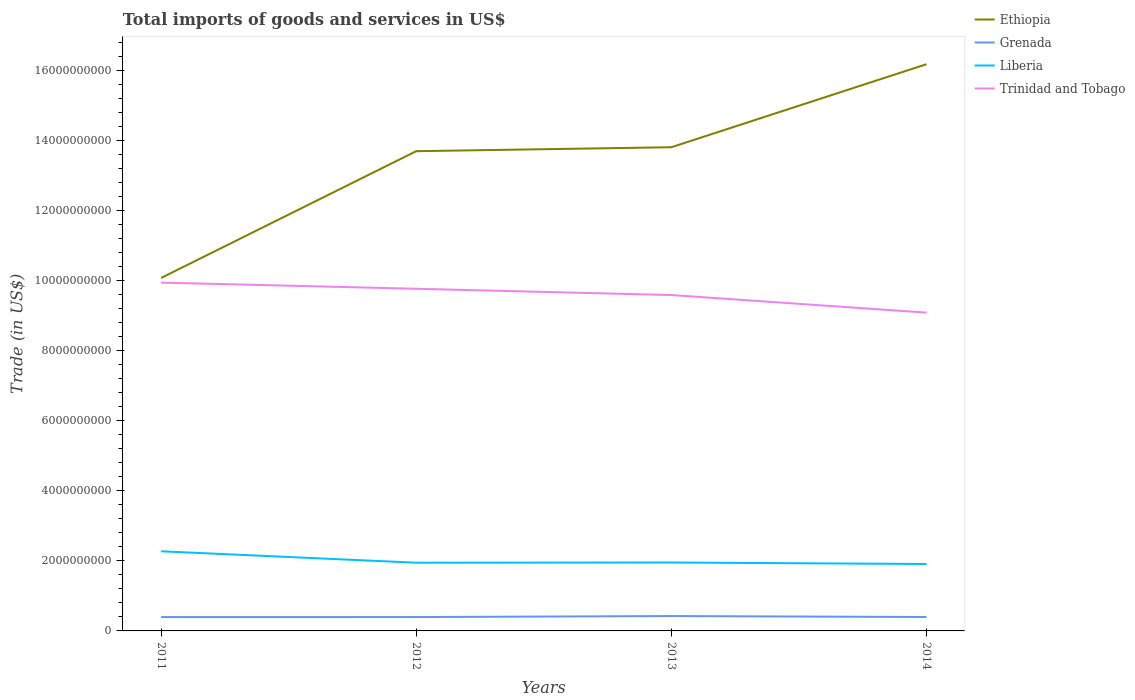Is the number of lines equal to the number of legend labels?
Offer a very short reply. Yes. Across all years, what is the maximum total imports of goods and services in Grenada?
Your answer should be compact. 3.95e+08. What is the total total imports of goods and services in Grenada in the graph?
Make the answer very short. -1.56e+06. What is the difference between the highest and the second highest total imports of goods and services in Trinidad and Tobago?
Offer a terse response. 8.57e+08. How many lines are there?
Keep it short and to the point. 4. How many years are there in the graph?
Offer a very short reply. 4. What is the difference between two consecutive major ticks on the Y-axis?
Keep it short and to the point. 2.00e+09. Does the graph contain any zero values?
Provide a succinct answer. No. Does the graph contain grids?
Keep it short and to the point. No. How many legend labels are there?
Ensure brevity in your answer.  4. What is the title of the graph?
Make the answer very short. Total imports of goods and services in US$. Does "Azerbaijan" appear as one of the legend labels in the graph?
Your response must be concise. No. What is the label or title of the X-axis?
Provide a short and direct response. Years. What is the label or title of the Y-axis?
Provide a succinct answer. Trade (in US$). What is the Trade (in US$) of Ethiopia in 2011?
Keep it short and to the point. 1.01e+1. What is the Trade (in US$) of Grenada in 2011?
Keep it short and to the point. 3.95e+08. What is the Trade (in US$) in Liberia in 2011?
Provide a succinct answer. 2.27e+09. What is the Trade (in US$) in Trinidad and Tobago in 2011?
Provide a short and direct response. 9.95e+09. What is the Trade (in US$) in Ethiopia in 2012?
Your response must be concise. 1.37e+1. What is the Trade (in US$) in Grenada in 2012?
Your answer should be very brief. 3.96e+08. What is the Trade (in US$) in Liberia in 2012?
Provide a succinct answer. 1.95e+09. What is the Trade (in US$) of Trinidad and Tobago in 2012?
Your answer should be very brief. 9.77e+09. What is the Trade (in US$) in Ethiopia in 2013?
Give a very brief answer. 1.38e+1. What is the Trade (in US$) of Grenada in 2013?
Your response must be concise. 4.24e+08. What is the Trade (in US$) of Liberia in 2013?
Your answer should be compact. 1.95e+09. What is the Trade (in US$) in Trinidad and Tobago in 2013?
Make the answer very short. 9.59e+09. What is the Trade (in US$) of Ethiopia in 2014?
Make the answer very short. 1.62e+1. What is the Trade (in US$) of Grenada in 2014?
Offer a very short reply. 3.97e+08. What is the Trade (in US$) of Liberia in 2014?
Your answer should be compact. 1.91e+09. What is the Trade (in US$) in Trinidad and Tobago in 2014?
Give a very brief answer. 9.09e+09. Across all years, what is the maximum Trade (in US$) of Ethiopia?
Offer a very short reply. 1.62e+1. Across all years, what is the maximum Trade (in US$) in Grenada?
Make the answer very short. 4.24e+08. Across all years, what is the maximum Trade (in US$) of Liberia?
Ensure brevity in your answer.  2.27e+09. Across all years, what is the maximum Trade (in US$) in Trinidad and Tobago?
Your response must be concise. 9.95e+09. Across all years, what is the minimum Trade (in US$) in Ethiopia?
Offer a terse response. 1.01e+1. Across all years, what is the minimum Trade (in US$) of Grenada?
Offer a very short reply. 3.95e+08. Across all years, what is the minimum Trade (in US$) of Liberia?
Your answer should be compact. 1.91e+09. Across all years, what is the minimum Trade (in US$) in Trinidad and Tobago?
Ensure brevity in your answer.  9.09e+09. What is the total Trade (in US$) of Ethiopia in the graph?
Your answer should be compact. 5.38e+1. What is the total Trade (in US$) in Grenada in the graph?
Ensure brevity in your answer.  1.61e+09. What is the total Trade (in US$) in Liberia in the graph?
Provide a succinct answer. 8.09e+09. What is the total Trade (in US$) of Trinidad and Tobago in the graph?
Keep it short and to the point. 3.84e+1. What is the difference between the Trade (in US$) of Ethiopia in 2011 and that in 2012?
Your answer should be very brief. -3.62e+09. What is the difference between the Trade (in US$) of Grenada in 2011 and that in 2012?
Make the answer very short. -1.89e+05. What is the difference between the Trade (in US$) of Liberia in 2011 and that in 2012?
Keep it short and to the point. 3.26e+08. What is the difference between the Trade (in US$) of Trinidad and Tobago in 2011 and that in 2012?
Make the answer very short. 1.76e+08. What is the difference between the Trade (in US$) of Ethiopia in 2011 and that in 2013?
Keep it short and to the point. -3.73e+09. What is the difference between the Trade (in US$) in Grenada in 2011 and that in 2013?
Make the answer very short. -2.88e+07. What is the difference between the Trade (in US$) in Liberia in 2011 and that in 2013?
Offer a terse response. 3.20e+08. What is the difference between the Trade (in US$) in Trinidad and Tobago in 2011 and that in 2013?
Your response must be concise. 3.55e+08. What is the difference between the Trade (in US$) of Ethiopia in 2011 and that in 2014?
Your answer should be compact. -6.10e+09. What is the difference between the Trade (in US$) in Grenada in 2011 and that in 2014?
Keep it short and to the point. -1.56e+06. What is the difference between the Trade (in US$) of Liberia in 2011 and that in 2014?
Your answer should be compact. 3.63e+08. What is the difference between the Trade (in US$) in Trinidad and Tobago in 2011 and that in 2014?
Keep it short and to the point. 8.57e+08. What is the difference between the Trade (in US$) of Ethiopia in 2012 and that in 2013?
Provide a succinct answer. -1.13e+08. What is the difference between the Trade (in US$) in Grenada in 2012 and that in 2013?
Provide a succinct answer. -2.86e+07. What is the difference between the Trade (in US$) of Liberia in 2012 and that in 2013?
Provide a short and direct response. -6.00e+06. What is the difference between the Trade (in US$) of Trinidad and Tobago in 2012 and that in 2013?
Give a very brief answer. 1.79e+08. What is the difference between the Trade (in US$) in Ethiopia in 2012 and that in 2014?
Your answer should be compact. -2.48e+09. What is the difference between the Trade (in US$) in Grenada in 2012 and that in 2014?
Your answer should be very brief. -1.37e+06. What is the difference between the Trade (in US$) in Liberia in 2012 and that in 2014?
Your answer should be very brief. 3.70e+07. What is the difference between the Trade (in US$) in Trinidad and Tobago in 2012 and that in 2014?
Make the answer very short. 6.81e+08. What is the difference between the Trade (in US$) in Ethiopia in 2013 and that in 2014?
Your response must be concise. -2.37e+09. What is the difference between the Trade (in US$) of Grenada in 2013 and that in 2014?
Ensure brevity in your answer.  2.72e+07. What is the difference between the Trade (in US$) of Liberia in 2013 and that in 2014?
Keep it short and to the point. 4.30e+07. What is the difference between the Trade (in US$) in Trinidad and Tobago in 2013 and that in 2014?
Your answer should be compact. 5.02e+08. What is the difference between the Trade (in US$) of Ethiopia in 2011 and the Trade (in US$) of Grenada in 2012?
Ensure brevity in your answer.  9.68e+09. What is the difference between the Trade (in US$) in Ethiopia in 2011 and the Trade (in US$) in Liberia in 2012?
Make the answer very short. 8.13e+09. What is the difference between the Trade (in US$) of Ethiopia in 2011 and the Trade (in US$) of Trinidad and Tobago in 2012?
Make the answer very short. 3.09e+08. What is the difference between the Trade (in US$) in Grenada in 2011 and the Trade (in US$) in Liberia in 2012?
Ensure brevity in your answer.  -1.55e+09. What is the difference between the Trade (in US$) of Grenada in 2011 and the Trade (in US$) of Trinidad and Tobago in 2012?
Give a very brief answer. -9.37e+09. What is the difference between the Trade (in US$) in Liberia in 2011 and the Trade (in US$) in Trinidad and Tobago in 2012?
Your answer should be very brief. -7.50e+09. What is the difference between the Trade (in US$) of Ethiopia in 2011 and the Trade (in US$) of Grenada in 2013?
Your answer should be compact. 9.66e+09. What is the difference between the Trade (in US$) of Ethiopia in 2011 and the Trade (in US$) of Liberia in 2013?
Your answer should be very brief. 8.13e+09. What is the difference between the Trade (in US$) in Ethiopia in 2011 and the Trade (in US$) in Trinidad and Tobago in 2013?
Offer a terse response. 4.89e+08. What is the difference between the Trade (in US$) in Grenada in 2011 and the Trade (in US$) in Liberia in 2013?
Ensure brevity in your answer.  -1.56e+09. What is the difference between the Trade (in US$) in Grenada in 2011 and the Trade (in US$) in Trinidad and Tobago in 2013?
Offer a terse response. -9.20e+09. What is the difference between the Trade (in US$) of Liberia in 2011 and the Trade (in US$) of Trinidad and Tobago in 2013?
Give a very brief answer. -7.32e+09. What is the difference between the Trade (in US$) in Ethiopia in 2011 and the Trade (in US$) in Grenada in 2014?
Provide a succinct answer. 9.68e+09. What is the difference between the Trade (in US$) in Ethiopia in 2011 and the Trade (in US$) in Liberia in 2014?
Keep it short and to the point. 8.17e+09. What is the difference between the Trade (in US$) of Ethiopia in 2011 and the Trade (in US$) of Trinidad and Tobago in 2014?
Make the answer very short. 9.90e+08. What is the difference between the Trade (in US$) in Grenada in 2011 and the Trade (in US$) in Liberia in 2014?
Offer a terse response. -1.52e+09. What is the difference between the Trade (in US$) in Grenada in 2011 and the Trade (in US$) in Trinidad and Tobago in 2014?
Provide a succinct answer. -8.69e+09. What is the difference between the Trade (in US$) in Liberia in 2011 and the Trade (in US$) in Trinidad and Tobago in 2014?
Keep it short and to the point. -6.82e+09. What is the difference between the Trade (in US$) in Ethiopia in 2012 and the Trade (in US$) in Grenada in 2013?
Provide a short and direct response. 1.33e+1. What is the difference between the Trade (in US$) in Ethiopia in 2012 and the Trade (in US$) in Liberia in 2013?
Keep it short and to the point. 1.17e+1. What is the difference between the Trade (in US$) in Ethiopia in 2012 and the Trade (in US$) in Trinidad and Tobago in 2013?
Your response must be concise. 4.11e+09. What is the difference between the Trade (in US$) in Grenada in 2012 and the Trade (in US$) in Liberia in 2013?
Offer a very short reply. -1.56e+09. What is the difference between the Trade (in US$) of Grenada in 2012 and the Trade (in US$) of Trinidad and Tobago in 2013?
Give a very brief answer. -9.20e+09. What is the difference between the Trade (in US$) in Liberia in 2012 and the Trade (in US$) in Trinidad and Tobago in 2013?
Provide a succinct answer. -7.64e+09. What is the difference between the Trade (in US$) in Ethiopia in 2012 and the Trade (in US$) in Grenada in 2014?
Provide a succinct answer. 1.33e+1. What is the difference between the Trade (in US$) in Ethiopia in 2012 and the Trade (in US$) in Liberia in 2014?
Your answer should be compact. 1.18e+1. What is the difference between the Trade (in US$) in Ethiopia in 2012 and the Trade (in US$) in Trinidad and Tobago in 2014?
Make the answer very short. 4.61e+09. What is the difference between the Trade (in US$) of Grenada in 2012 and the Trade (in US$) of Liberia in 2014?
Your answer should be very brief. -1.52e+09. What is the difference between the Trade (in US$) of Grenada in 2012 and the Trade (in US$) of Trinidad and Tobago in 2014?
Give a very brief answer. -8.69e+09. What is the difference between the Trade (in US$) in Liberia in 2012 and the Trade (in US$) in Trinidad and Tobago in 2014?
Offer a very short reply. -7.14e+09. What is the difference between the Trade (in US$) of Ethiopia in 2013 and the Trade (in US$) of Grenada in 2014?
Your response must be concise. 1.34e+1. What is the difference between the Trade (in US$) of Ethiopia in 2013 and the Trade (in US$) of Liberia in 2014?
Your answer should be compact. 1.19e+1. What is the difference between the Trade (in US$) of Ethiopia in 2013 and the Trade (in US$) of Trinidad and Tobago in 2014?
Ensure brevity in your answer.  4.72e+09. What is the difference between the Trade (in US$) in Grenada in 2013 and the Trade (in US$) in Liberia in 2014?
Keep it short and to the point. -1.49e+09. What is the difference between the Trade (in US$) in Grenada in 2013 and the Trade (in US$) in Trinidad and Tobago in 2014?
Provide a short and direct response. -8.67e+09. What is the difference between the Trade (in US$) in Liberia in 2013 and the Trade (in US$) in Trinidad and Tobago in 2014?
Give a very brief answer. -7.14e+09. What is the average Trade (in US$) in Ethiopia per year?
Make the answer very short. 1.34e+1. What is the average Trade (in US$) of Grenada per year?
Your answer should be very brief. 4.03e+08. What is the average Trade (in US$) of Liberia per year?
Your answer should be compact. 2.02e+09. What is the average Trade (in US$) in Trinidad and Tobago per year?
Keep it short and to the point. 9.60e+09. In the year 2011, what is the difference between the Trade (in US$) in Ethiopia and Trade (in US$) in Grenada?
Your answer should be compact. 9.68e+09. In the year 2011, what is the difference between the Trade (in US$) of Ethiopia and Trade (in US$) of Liberia?
Ensure brevity in your answer.  7.81e+09. In the year 2011, what is the difference between the Trade (in US$) in Ethiopia and Trade (in US$) in Trinidad and Tobago?
Make the answer very short. 1.33e+08. In the year 2011, what is the difference between the Trade (in US$) of Grenada and Trade (in US$) of Liberia?
Your answer should be compact. -1.88e+09. In the year 2011, what is the difference between the Trade (in US$) of Grenada and Trade (in US$) of Trinidad and Tobago?
Your answer should be compact. -9.55e+09. In the year 2011, what is the difference between the Trade (in US$) of Liberia and Trade (in US$) of Trinidad and Tobago?
Provide a succinct answer. -7.67e+09. In the year 2012, what is the difference between the Trade (in US$) of Ethiopia and Trade (in US$) of Grenada?
Your answer should be compact. 1.33e+1. In the year 2012, what is the difference between the Trade (in US$) in Ethiopia and Trade (in US$) in Liberia?
Your answer should be compact. 1.18e+1. In the year 2012, what is the difference between the Trade (in US$) in Ethiopia and Trade (in US$) in Trinidad and Tobago?
Your answer should be very brief. 3.93e+09. In the year 2012, what is the difference between the Trade (in US$) in Grenada and Trade (in US$) in Liberia?
Offer a very short reply. -1.55e+09. In the year 2012, what is the difference between the Trade (in US$) of Grenada and Trade (in US$) of Trinidad and Tobago?
Offer a very short reply. -9.37e+09. In the year 2012, what is the difference between the Trade (in US$) in Liberia and Trade (in US$) in Trinidad and Tobago?
Offer a very short reply. -7.82e+09. In the year 2013, what is the difference between the Trade (in US$) in Ethiopia and Trade (in US$) in Grenada?
Your answer should be compact. 1.34e+1. In the year 2013, what is the difference between the Trade (in US$) in Ethiopia and Trade (in US$) in Liberia?
Your answer should be very brief. 1.19e+1. In the year 2013, what is the difference between the Trade (in US$) of Ethiopia and Trade (in US$) of Trinidad and Tobago?
Give a very brief answer. 4.22e+09. In the year 2013, what is the difference between the Trade (in US$) in Grenada and Trade (in US$) in Liberia?
Provide a short and direct response. -1.53e+09. In the year 2013, what is the difference between the Trade (in US$) in Grenada and Trade (in US$) in Trinidad and Tobago?
Provide a short and direct response. -9.17e+09. In the year 2013, what is the difference between the Trade (in US$) in Liberia and Trade (in US$) in Trinidad and Tobago?
Provide a succinct answer. -7.64e+09. In the year 2014, what is the difference between the Trade (in US$) of Ethiopia and Trade (in US$) of Grenada?
Provide a succinct answer. 1.58e+1. In the year 2014, what is the difference between the Trade (in US$) of Ethiopia and Trade (in US$) of Liberia?
Offer a terse response. 1.43e+1. In the year 2014, what is the difference between the Trade (in US$) of Ethiopia and Trade (in US$) of Trinidad and Tobago?
Offer a terse response. 7.09e+09. In the year 2014, what is the difference between the Trade (in US$) in Grenada and Trade (in US$) in Liberia?
Make the answer very short. -1.51e+09. In the year 2014, what is the difference between the Trade (in US$) in Grenada and Trade (in US$) in Trinidad and Tobago?
Make the answer very short. -8.69e+09. In the year 2014, what is the difference between the Trade (in US$) of Liberia and Trade (in US$) of Trinidad and Tobago?
Your response must be concise. -7.18e+09. What is the ratio of the Trade (in US$) of Ethiopia in 2011 to that in 2012?
Your answer should be compact. 0.74. What is the ratio of the Trade (in US$) in Grenada in 2011 to that in 2012?
Ensure brevity in your answer.  1. What is the ratio of the Trade (in US$) of Liberia in 2011 to that in 2012?
Provide a short and direct response. 1.17. What is the ratio of the Trade (in US$) in Ethiopia in 2011 to that in 2013?
Provide a succinct answer. 0.73. What is the ratio of the Trade (in US$) in Grenada in 2011 to that in 2013?
Your answer should be very brief. 0.93. What is the ratio of the Trade (in US$) in Liberia in 2011 to that in 2013?
Make the answer very short. 1.16. What is the ratio of the Trade (in US$) in Ethiopia in 2011 to that in 2014?
Give a very brief answer. 0.62. What is the ratio of the Trade (in US$) in Liberia in 2011 to that in 2014?
Offer a very short reply. 1.19. What is the ratio of the Trade (in US$) in Trinidad and Tobago in 2011 to that in 2014?
Give a very brief answer. 1.09. What is the ratio of the Trade (in US$) of Grenada in 2012 to that in 2013?
Ensure brevity in your answer.  0.93. What is the ratio of the Trade (in US$) of Trinidad and Tobago in 2012 to that in 2013?
Ensure brevity in your answer.  1.02. What is the ratio of the Trade (in US$) of Ethiopia in 2012 to that in 2014?
Your response must be concise. 0.85. What is the ratio of the Trade (in US$) in Liberia in 2012 to that in 2014?
Ensure brevity in your answer.  1.02. What is the ratio of the Trade (in US$) of Trinidad and Tobago in 2012 to that in 2014?
Give a very brief answer. 1.07. What is the ratio of the Trade (in US$) in Ethiopia in 2013 to that in 2014?
Provide a succinct answer. 0.85. What is the ratio of the Trade (in US$) in Grenada in 2013 to that in 2014?
Your answer should be very brief. 1.07. What is the ratio of the Trade (in US$) in Liberia in 2013 to that in 2014?
Offer a terse response. 1.02. What is the ratio of the Trade (in US$) in Trinidad and Tobago in 2013 to that in 2014?
Your answer should be very brief. 1.06. What is the difference between the highest and the second highest Trade (in US$) in Ethiopia?
Your answer should be compact. 2.37e+09. What is the difference between the highest and the second highest Trade (in US$) of Grenada?
Make the answer very short. 2.72e+07. What is the difference between the highest and the second highest Trade (in US$) of Liberia?
Your answer should be compact. 3.20e+08. What is the difference between the highest and the second highest Trade (in US$) in Trinidad and Tobago?
Provide a short and direct response. 1.76e+08. What is the difference between the highest and the lowest Trade (in US$) of Ethiopia?
Your response must be concise. 6.10e+09. What is the difference between the highest and the lowest Trade (in US$) of Grenada?
Offer a very short reply. 2.88e+07. What is the difference between the highest and the lowest Trade (in US$) in Liberia?
Offer a very short reply. 3.63e+08. What is the difference between the highest and the lowest Trade (in US$) of Trinidad and Tobago?
Make the answer very short. 8.57e+08. 